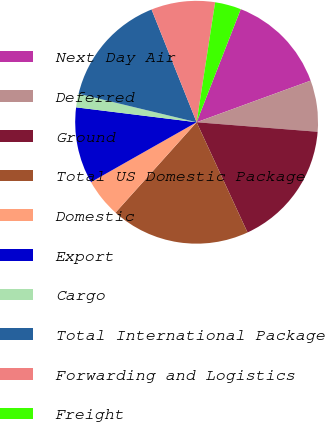Convert chart to OTSL. <chart><loc_0><loc_0><loc_500><loc_500><pie_chart><fcel>Next Day Air<fcel>Deferred<fcel>Ground<fcel>Total US Domestic Package<fcel>Domestic<fcel>Export<fcel>Cargo<fcel>Total International Package<fcel>Forwarding and Logistics<fcel>Freight<nl><fcel>13.51%<fcel>6.82%<fcel>16.86%<fcel>18.53%<fcel>5.15%<fcel>10.17%<fcel>1.81%<fcel>15.18%<fcel>8.49%<fcel>3.48%<nl></chart> 